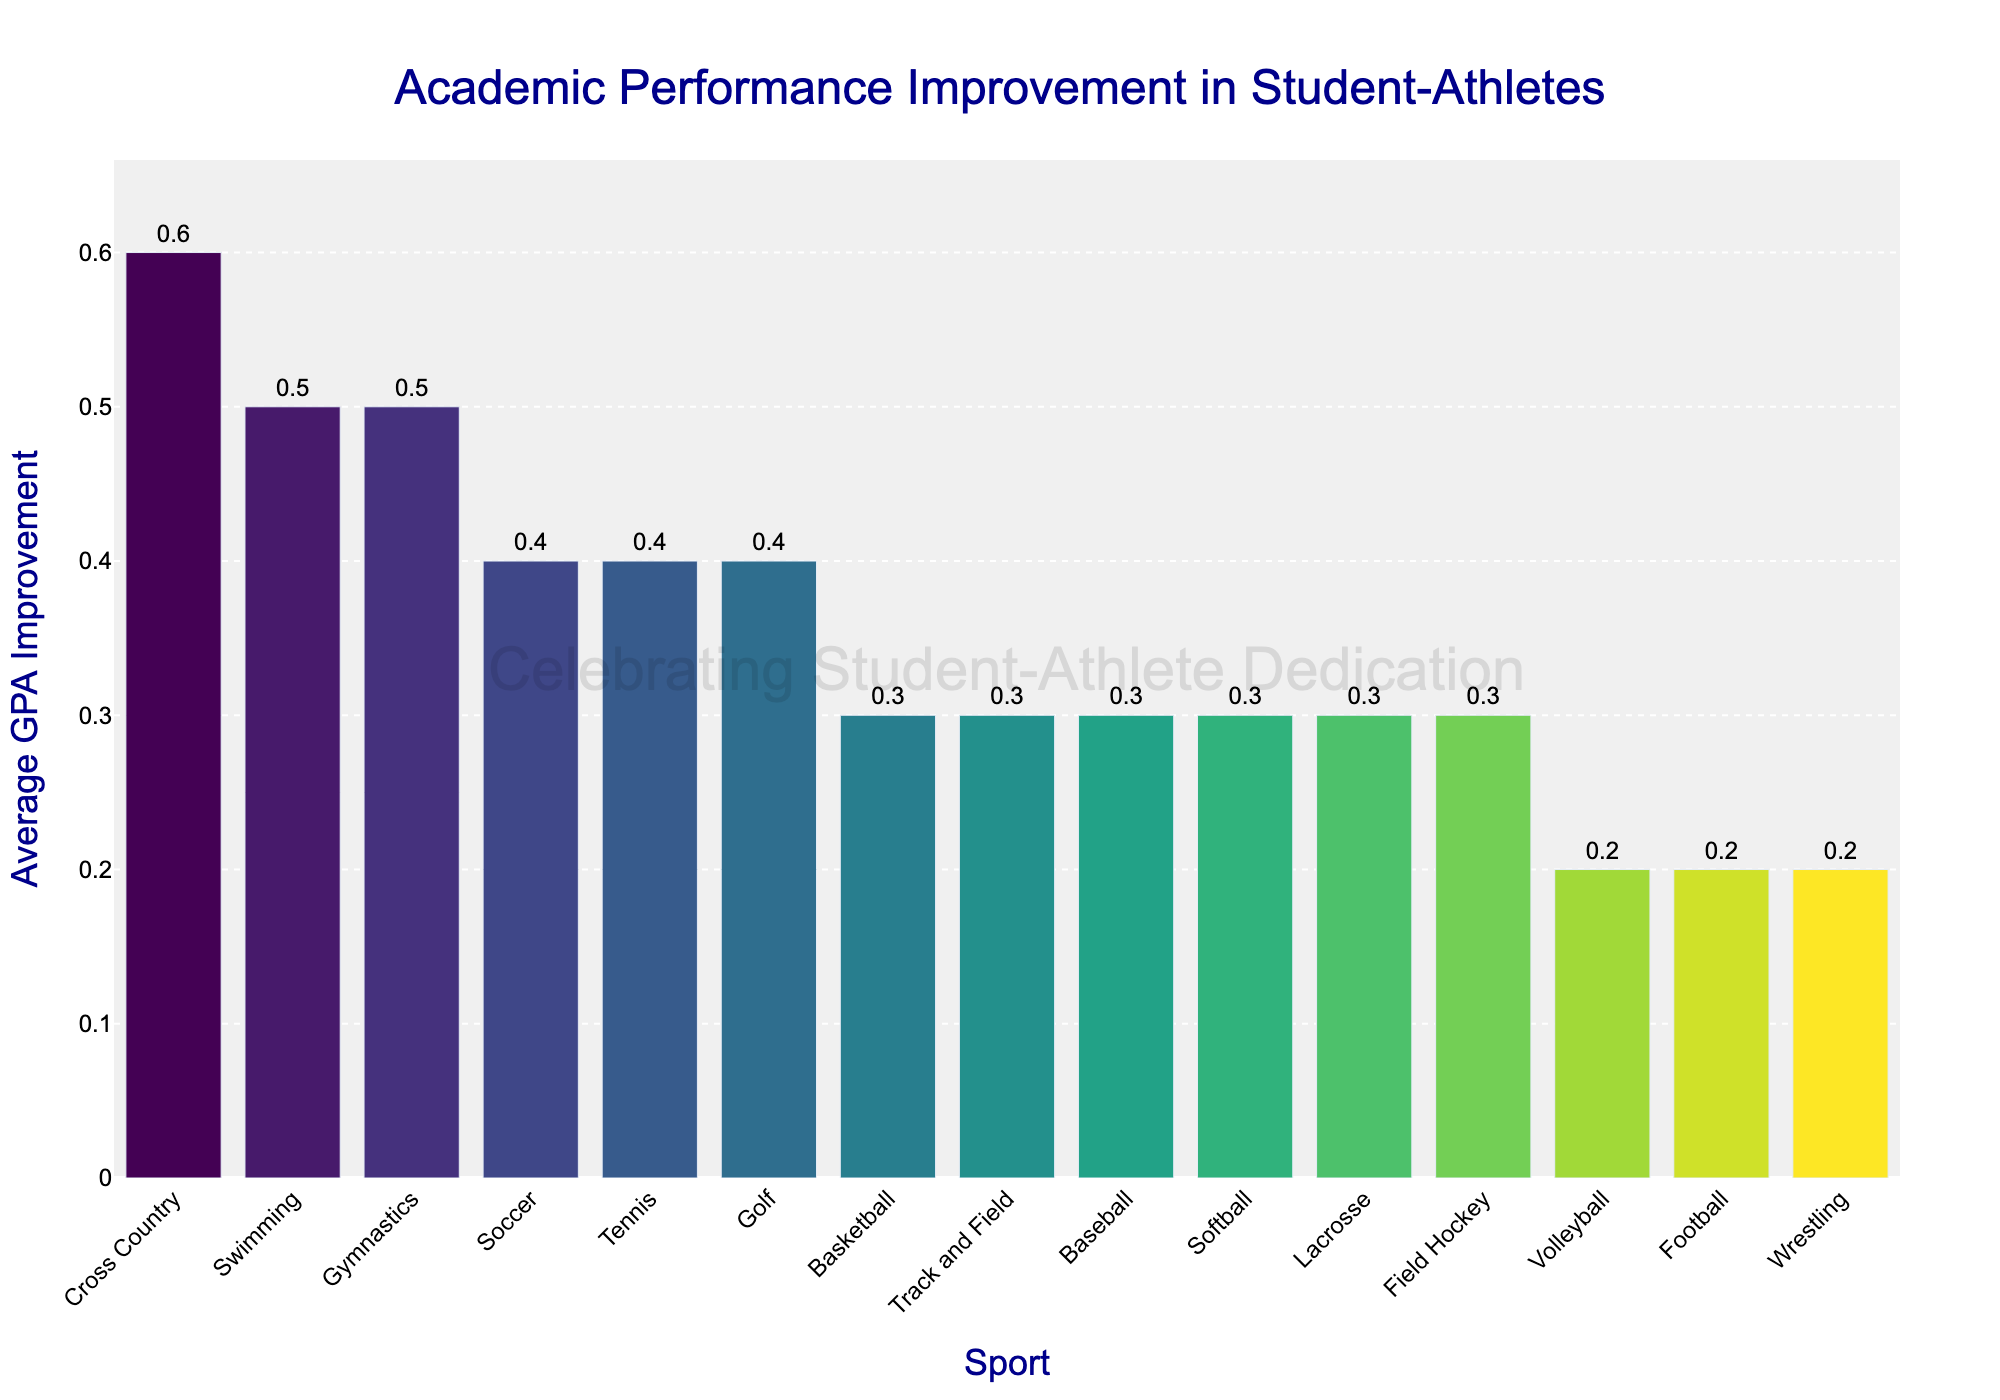What's the sport with the highest average GPA improvement? The bar chart shows Cross Country with the highest bar, indicating the highest average GPA improvement.
Answer: Cross Country Which two sports have the same average GPA improvement and what is that improvement? Looking at the chart, Basketball, Track and Field, Baseball, Softball, Lacrosse, and Field Hockey all share the same average GPA improvement, which is 0.3.
Answer: Basketball, Track and Field, Baseball, Softball, Lacrosse, Field Hockey; 0.3 Calculate the difference in average GPA improvement between Swimming and Football. Swimming has a bar representing a 0.5 GPA improvement and Football a 0.2. The difference is calculated as 0.5 - 0.2 = 0.3.
Answer: 0.3 Which sport shows a lower average GPA improvement: Volleyball or Tennis, and by how much? Volleyball has a GPA improvement of 0.2, while Tennis has 0.4. The difference is 0.4 - 0.2 = 0.2.
Answer: Volleyball, by 0.2 Rank the top three sports in terms of average GPA improvement. By visually inspecting the height of the bars, the top three sports are Cross Country (0.6), Swimming and Gymnastics (both 0.5).
Answer: Cross Country, Swimming, Gymnastics What is the average GPA improvement for the top four sports combined? Adding the GPA improvements of Cross Country (0.6), Swimming (0.5), Gymnastics (0.5), and Soccer (0.4) results in 2.0. The average is 2.0 / 4 = 0.5.
Answer: 0.5 Which sport has the second-lowest average GPA improvement and what is the value? Football, Volleyball, and Wrestling all have an average GPA improvement of 0.2, the minimum value, but as per sorting, Volleyball is the second-lowest.
Answer: Volleyball, 0.2 What is the combined total average GPA improvement for sports with a 0.3 improvement? There are six sports with a 0.3 GPA improvement. Their combined total is 6 * 0.3 = 1.8.
Answer: 1.8 Is the average GPA improvement for Soccer higher or lower than Tennis? Both Soccer and Tennis have the same average GPA improvement of 0.4, so neither is higher or lower.
Answer: Equal If you were to group the sports into two categories: those above a GPA improvement of 0.3 and those equal to or below 0.3, how many sports fall into each category? Grouping the sports into those with GPA improvements greater than 0.3 (Cross Country, Swimming, Gymnastics, Soccer, Tennis, and Golf—total 6 sports), and those with GPA improvement less than or equal to 0.3 (the remaining 9 sports)
Answer: 6 above 0.3; 9 equal to or below 0.3 